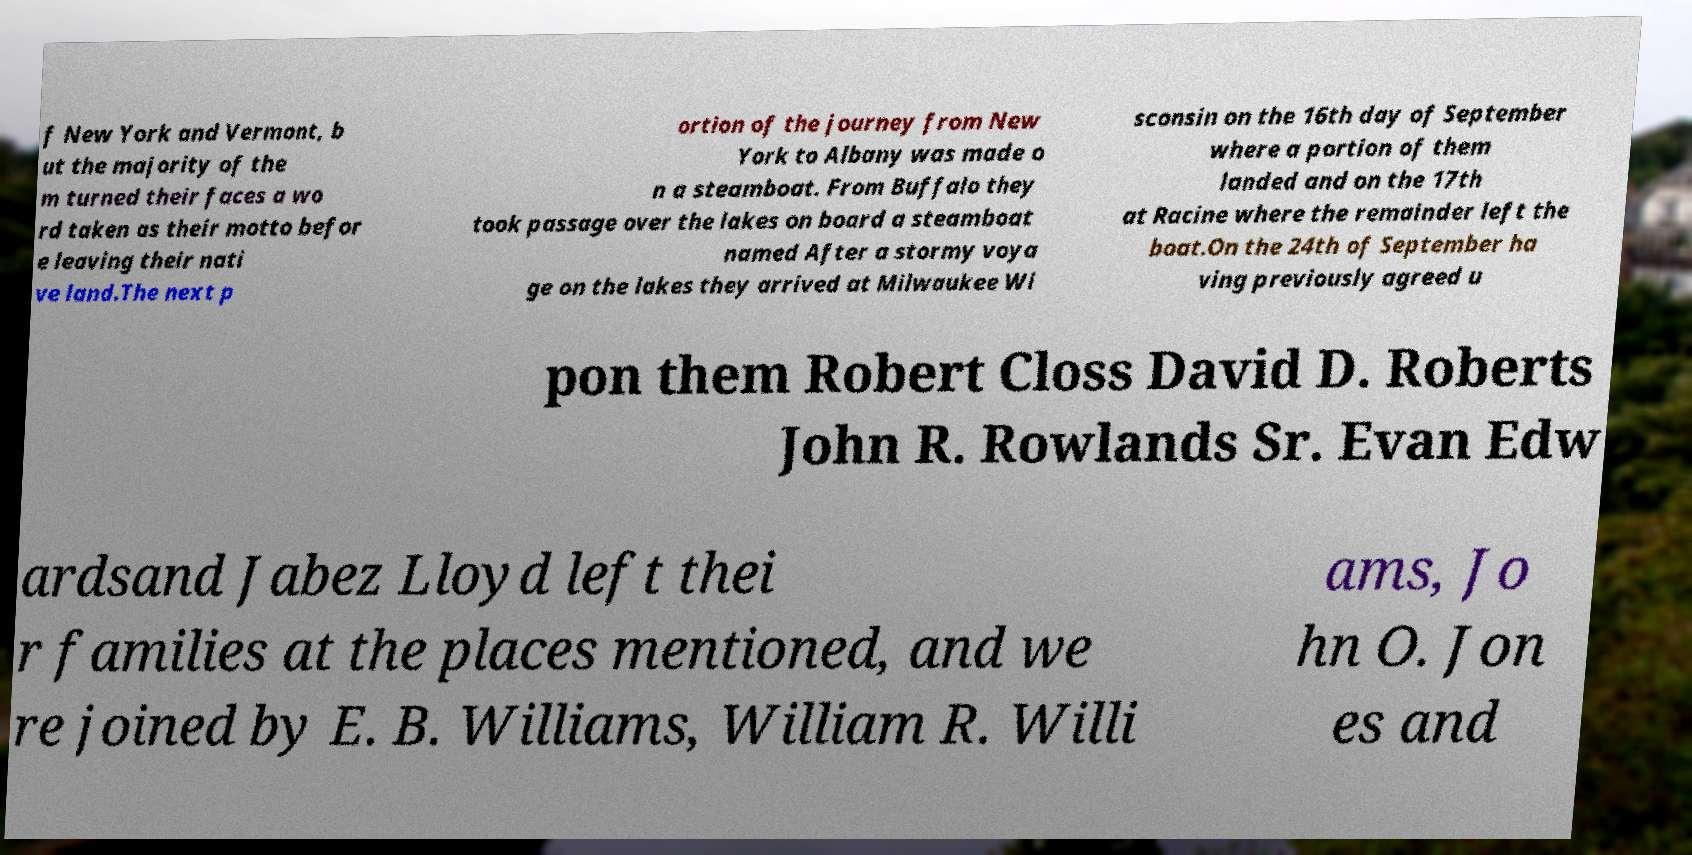For documentation purposes, I need the text within this image transcribed. Could you provide that? f New York and Vermont, b ut the majority of the m turned their faces a wo rd taken as their motto befor e leaving their nati ve land.The next p ortion of the journey from New York to Albany was made o n a steamboat. From Buffalo they took passage over the lakes on board a steamboat named After a stormy voya ge on the lakes they arrived at Milwaukee Wi sconsin on the 16th day of September where a portion of them landed and on the 17th at Racine where the remainder left the boat.On the 24th of September ha ving previously agreed u pon them Robert Closs David D. Roberts John R. Rowlands Sr. Evan Edw ardsand Jabez Lloyd left thei r families at the places mentioned, and we re joined by E. B. Williams, William R. Willi ams, Jo hn O. Jon es and 